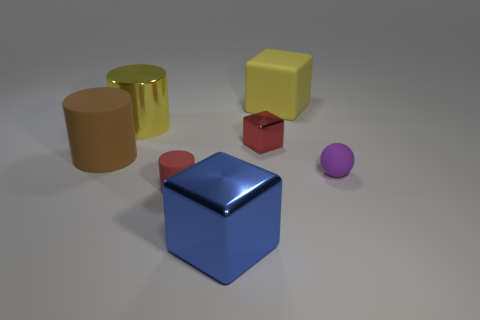Add 1 yellow metallic cylinders. How many objects exist? 8 Subtract all blocks. How many objects are left? 4 Add 6 red matte things. How many red matte things are left? 7 Add 2 yellow shiny cylinders. How many yellow shiny cylinders exist? 3 Subtract 1 purple balls. How many objects are left? 6 Subtract all purple balls. Subtract all small balls. How many objects are left? 5 